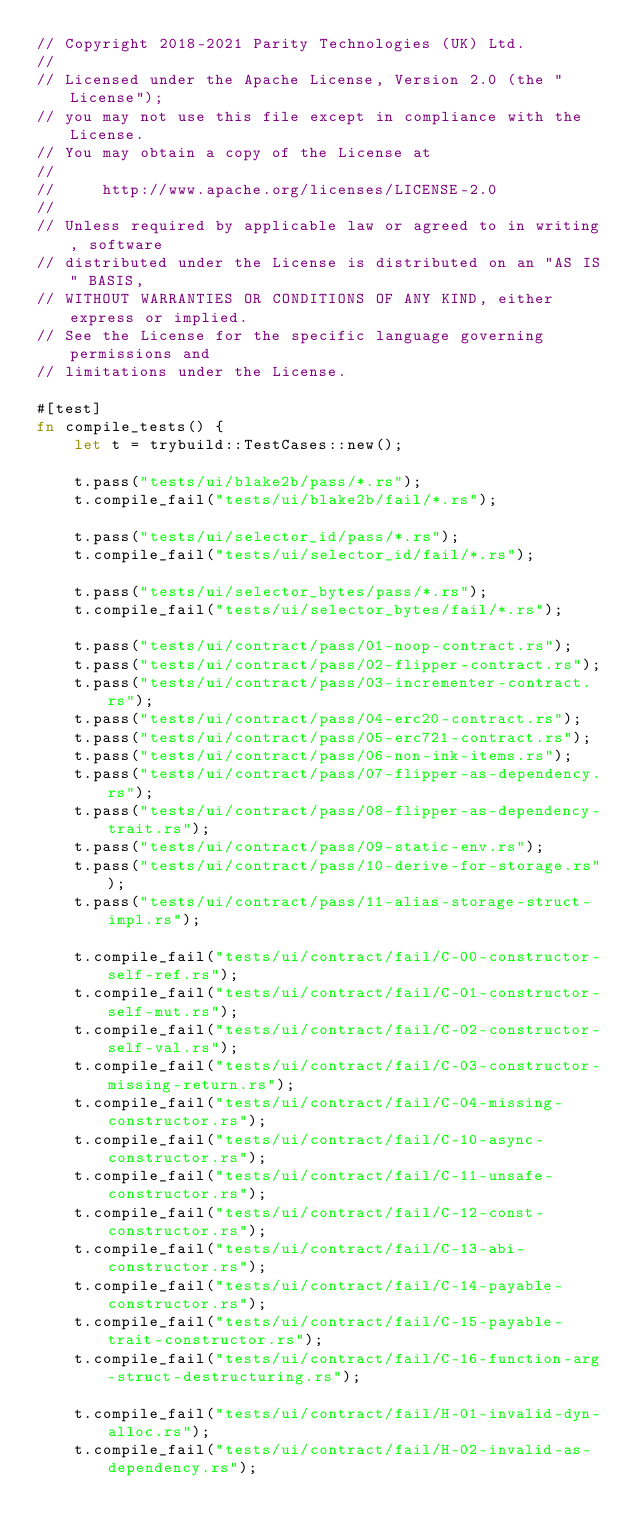Convert code to text. <code><loc_0><loc_0><loc_500><loc_500><_Rust_>// Copyright 2018-2021 Parity Technologies (UK) Ltd.
//
// Licensed under the Apache License, Version 2.0 (the "License");
// you may not use this file except in compliance with the License.
// You may obtain a copy of the License at
//
//     http://www.apache.org/licenses/LICENSE-2.0
//
// Unless required by applicable law or agreed to in writing, software
// distributed under the License is distributed on an "AS IS" BASIS,
// WITHOUT WARRANTIES OR CONDITIONS OF ANY KIND, either express or implied.
// See the License for the specific language governing permissions and
// limitations under the License.

#[test]
fn compile_tests() {
    let t = trybuild::TestCases::new();

    t.pass("tests/ui/blake2b/pass/*.rs");
    t.compile_fail("tests/ui/blake2b/fail/*.rs");

    t.pass("tests/ui/selector_id/pass/*.rs");
    t.compile_fail("tests/ui/selector_id/fail/*.rs");

    t.pass("tests/ui/selector_bytes/pass/*.rs");
    t.compile_fail("tests/ui/selector_bytes/fail/*.rs");

    t.pass("tests/ui/contract/pass/01-noop-contract.rs");
    t.pass("tests/ui/contract/pass/02-flipper-contract.rs");
    t.pass("tests/ui/contract/pass/03-incrementer-contract.rs");
    t.pass("tests/ui/contract/pass/04-erc20-contract.rs");
    t.pass("tests/ui/contract/pass/05-erc721-contract.rs");
    t.pass("tests/ui/contract/pass/06-non-ink-items.rs");
    t.pass("tests/ui/contract/pass/07-flipper-as-dependency.rs");
    t.pass("tests/ui/contract/pass/08-flipper-as-dependency-trait.rs");
    t.pass("tests/ui/contract/pass/09-static-env.rs");
    t.pass("tests/ui/contract/pass/10-derive-for-storage.rs");
    t.pass("tests/ui/contract/pass/11-alias-storage-struct-impl.rs");

    t.compile_fail("tests/ui/contract/fail/C-00-constructor-self-ref.rs");
    t.compile_fail("tests/ui/contract/fail/C-01-constructor-self-mut.rs");
    t.compile_fail("tests/ui/contract/fail/C-02-constructor-self-val.rs");
    t.compile_fail("tests/ui/contract/fail/C-03-constructor-missing-return.rs");
    t.compile_fail("tests/ui/contract/fail/C-04-missing-constructor.rs");
    t.compile_fail("tests/ui/contract/fail/C-10-async-constructor.rs");
    t.compile_fail("tests/ui/contract/fail/C-11-unsafe-constructor.rs");
    t.compile_fail("tests/ui/contract/fail/C-12-const-constructor.rs");
    t.compile_fail("tests/ui/contract/fail/C-13-abi-constructor.rs");
    t.compile_fail("tests/ui/contract/fail/C-14-payable-constructor.rs");
    t.compile_fail("tests/ui/contract/fail/C-15-payable-trait-constructor.rs");
    t.compile_fail("tests/ui/contract/fail/C-16-function-arg-struct-destructuring.rs");

    t.compile_fail("tests/ui/contract/fail/H-01-invalid-dyn-alloc.rs");
    t.compile_fail("tests/ui/contract/fail/H-02-invalid-as-dependency.rs");</code> 